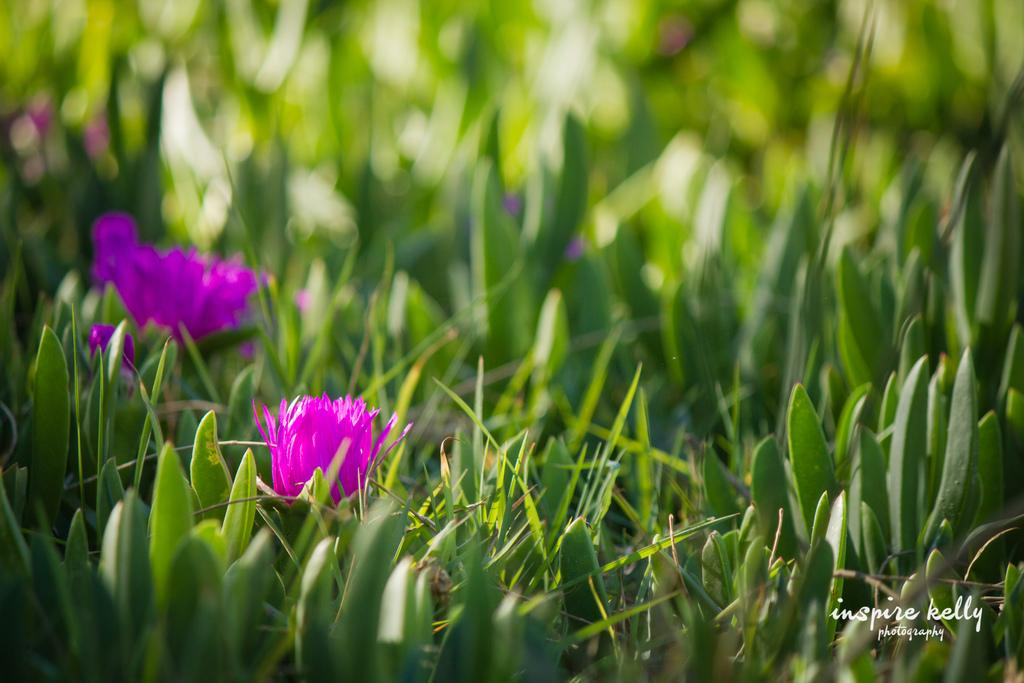What type of vegetation is present in the image? There is grass and flowers in the image. Can you describe the colors of the flowers? The colors of the flowers cannot be determined from the provided facts. What might be the purpose of the grass in the image? The grass in the image might be part of a natural landscape or garden. What is the topic of the argument taking place in the image? There is no argument present in the image; it only features grass and flowers. How many times does the rake appear in the image? There is no rake present in the image. 